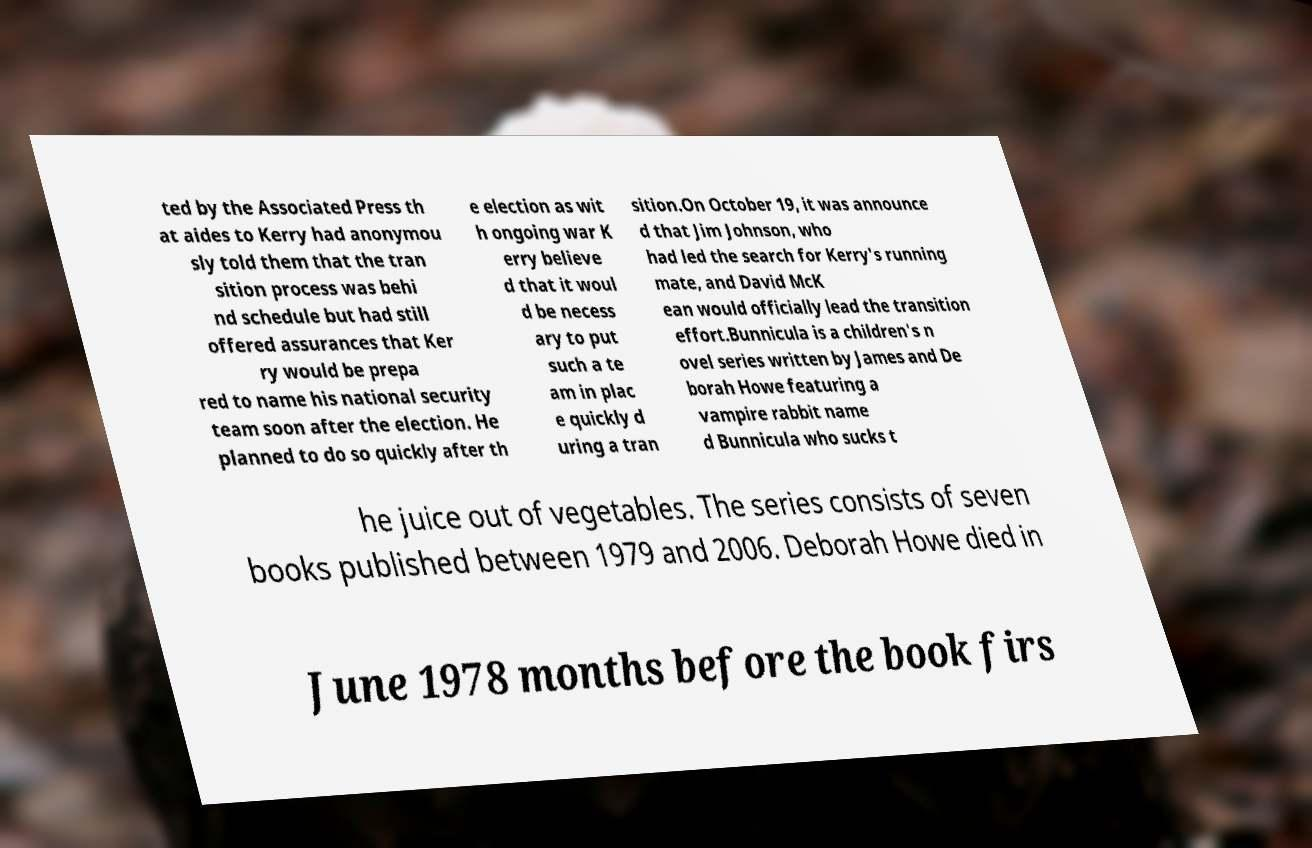Please read and relay the text visible in this image. What does it say? ted by the Associated Press th at aides to Kerry had anonymou sly told them that the tran sition process was behi nd schedule but had still offered assurances that Ker ry would be prepa red to name his national security team soon after the election. He planned to do so quickly after th e election as wit h ongoing war K erry believe d that it woul d be necess ary to put such a te am in plac e quickly d uring a tran sition.On October 19, it was announce d that Jim Johnson, who had led the search for Kerry's running mate, and David McK ean would officially lead the transition effort.Bunnicula is a children's n ovel series written by James and De borah Howe featuring a vampire rabbit name d Bunnicula who sucks t he juice out of vegetables. The series consists of seven books published between 1979 and 2006. Deborah Howe died in June 1978 months before the book firs 